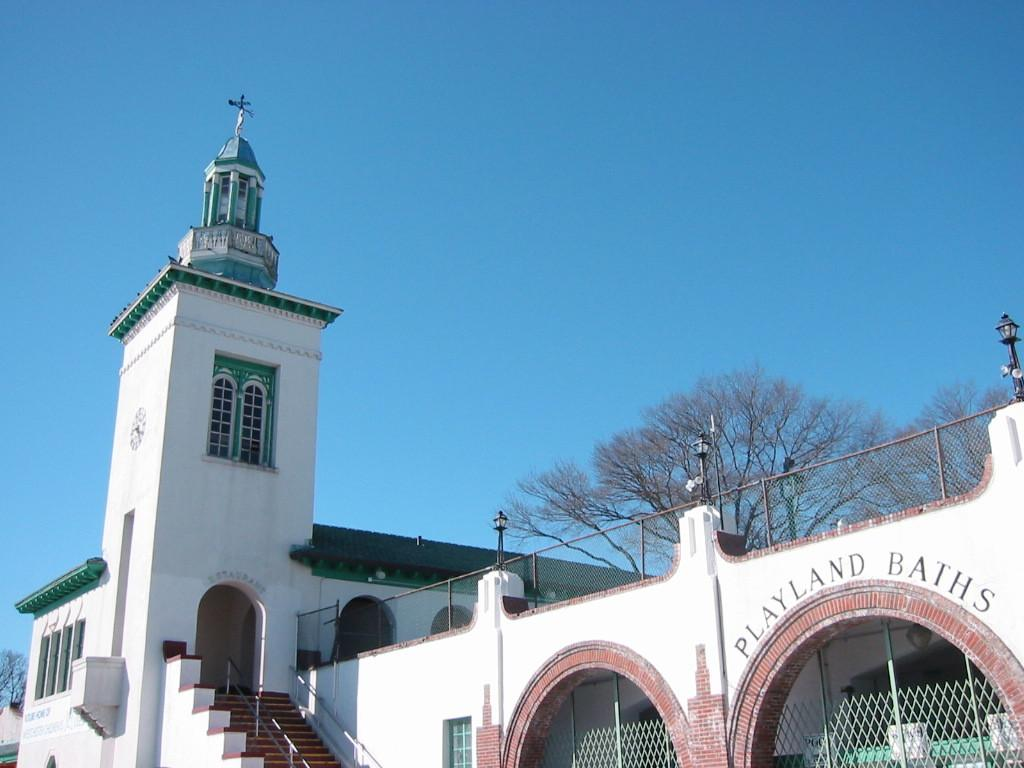What type of structure is present in the image? There is a building in the image. What can be seen in the background of the image? There are trees and the sky visible in the background of the image. What architectural feature is present at the bottom of the image? There are stairs at the bottom of the image. What type of feather can be seen on the roof of the building in the image? There is no feather present on the roof of the building in the image. 